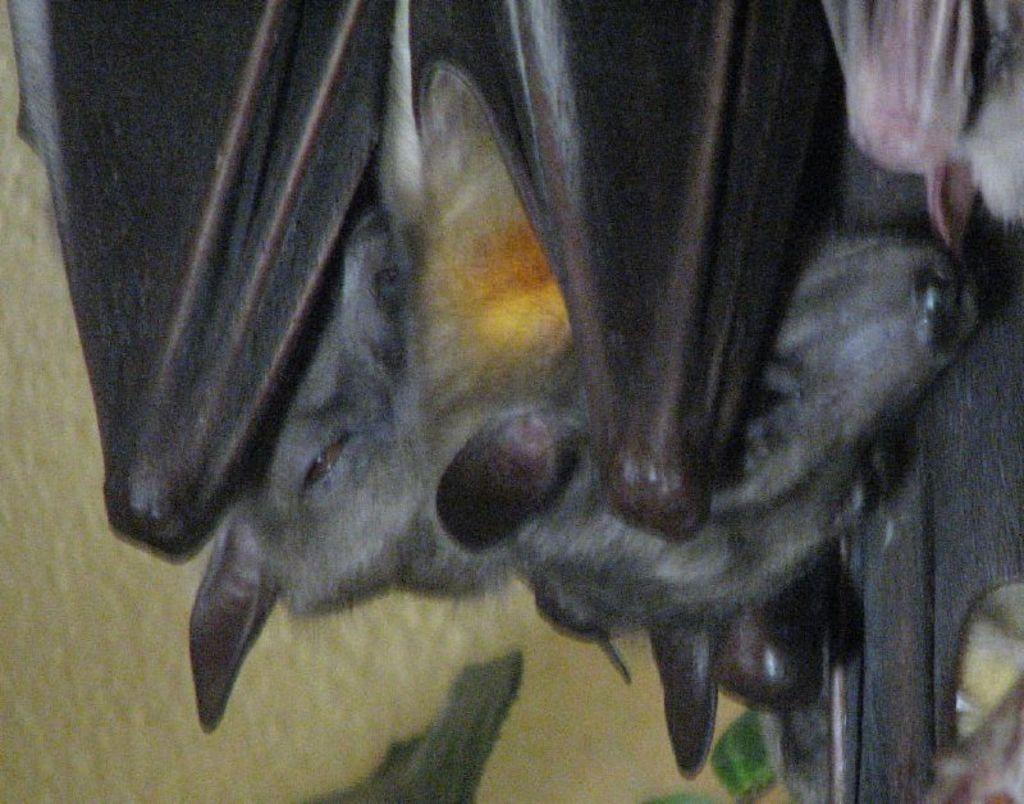What objects are present in the image? There are two bolts in the image. What can be said about the appearance of the bolts? The bolts are gray in color and have black wings. What is visible in the background of the image? There is a yellow wall in the background of the image. What type of furniture is depicted in the image? There is no furniture present in the image; it features two bolts with wings. Can you describe the stick that the bolts are holding in the image? There is no stick or any indication of the bolts holding anything in the image. 